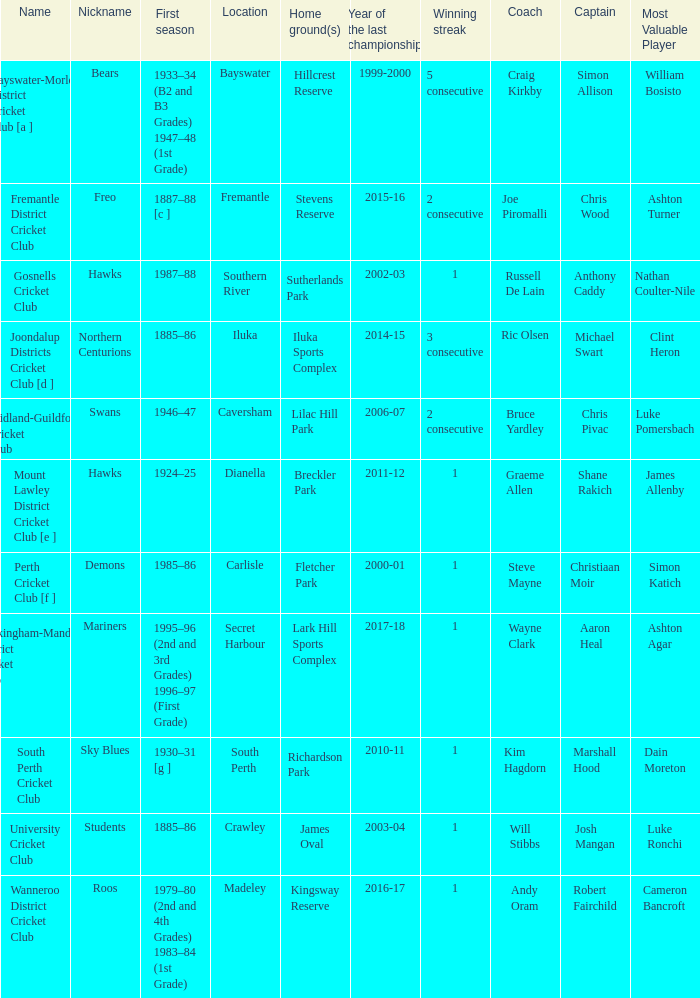Parse the full table. {'header': ['Name', 'Nickname', 'First season', 'Location', 'Home ground(s)', 'Year of the last championship', 'Winning streak', 'Coach', 'Captain', 'Most Valuable Player'], 'rows': [['Bayswater-Morley District Cricket Club [a ]', 'Bears', '1933–34 (B2 and B3 Grades) 1947–48 (1st Grade)', 'Bayswater', 'Hillcrest Reserve', '1999-2000', '5 consecutive', 'Craig Kirkby', 'Simon Allison', 'William Bosisto '], ['Fremantle District Cricket Club', 'Freo', '1887–88 [c ]', 'Fremantle', 'Stevens Reserve', '2015-16', '2 consecutive', 'Joe Piromalli', 'Chris Wood', 'Ashton Turner'], ['Gosnells Cricket Club', 'Hawks', '1987–88', 'Southern River', 'Sutherlands Park', '2002-03', '1', 'Russell De Lain', 'Anthony Caddy', 'Nathan Coulter-Nile'], ['Joondalup Districts Cricket Club [d ]', 'Northern Centurions', '1885–86', 'Iluka', 'Iluka Sports Complex', '2014-15', '3 consecutive', 'Ric Olsen', 'Michael Swart', 'Clint Heron'], ['Midland-Guildford Cricket Club', 'Swans', '1946–47', 'Caversham', 'Lilac Hill Park', '2006-07', '2 consecutive', 'Bruce Yardley', 'Chris Pivac', 'Luke Pomersbach'], ['Mount Lawley District Cricket Club [e ]', 'Hawks', '1924–25', 'Dianella', 'Breckler Park', '2011-12', '1', 'Graeme Allen', 'Shane Rakich', 'James Allenby'], ['Perth Cricket Club [f ]', 'Demons', '1985–86', 'Carlisle', 'Fletcher Park', '2000-01', '1', 'Steve Mayne', 'Christiaan Moir', 'Simon Katich'], ['Rockingham-Mandurah District Cricket Club', 'Mariners', '1995–96 (2nd and 3rd Grades) 1996–97 (First Grade)', 'Secret Harbour', 'Lark Hill Sports Complex', '2017-18', '1', 'Wayne Clark', 'Aaron Heal', 'Ashton Agar'], ['South Perth Cricket Club', 'Sky Blues', '1930–31 [g ]', 'South Perth', 'Richardson Park', '2010-11', '1', 'Kim Hagdorn', 'Marshall Hood', 'Dain Moreton'], ['University Cricket Club', 'Students', '1885–86', 'Crawley', 'James Oval', '2003-04', '1', 'Will Stibbs', 'Josh Mangan', 'Luke Ronchi'], ['Wanneroo District Cricket Club', 'Roos', '1979–80 (2nd and 4th Grades) 1983–84 (1st Grade)', 'Madeley', 'Kingsway Reserve', '2016-17', '1', 'Andy Oram', 'Robert Fairchild', 'Cameron Bancroft']]} For location Caversham, what is the name of the captain? Chris Pivac. 